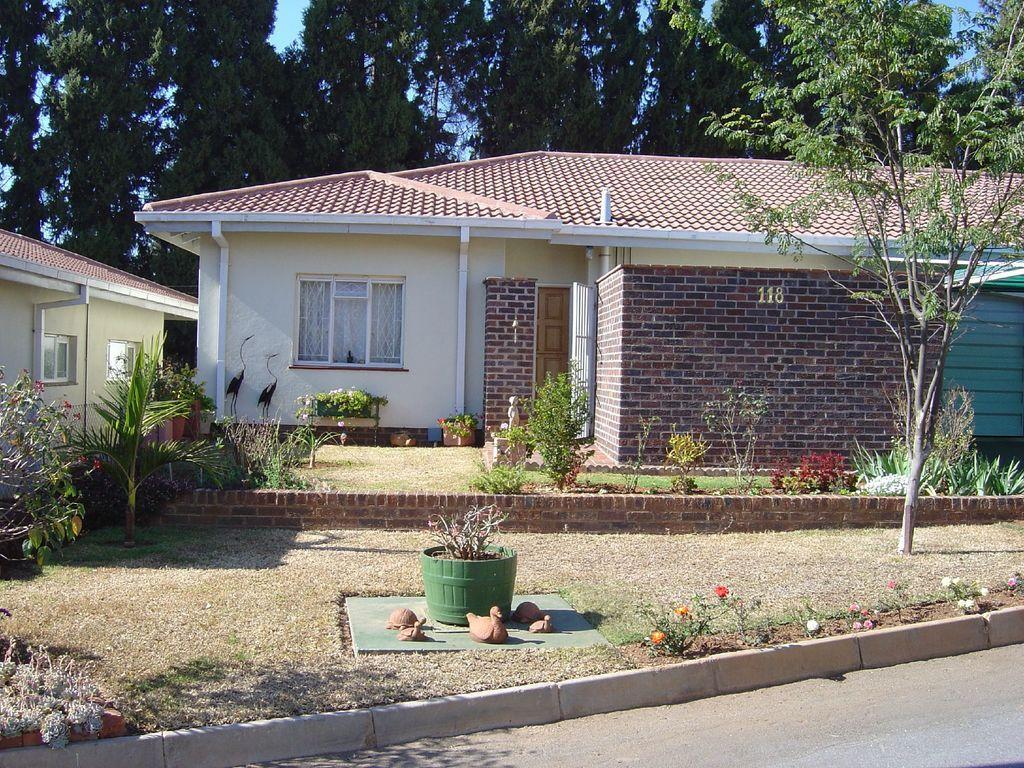In one or two sentences, can you explain what this image depicts? This picture shows couple of houses and we see plants and trees and we see few toys and grass on the ground and we see few flower plants. 